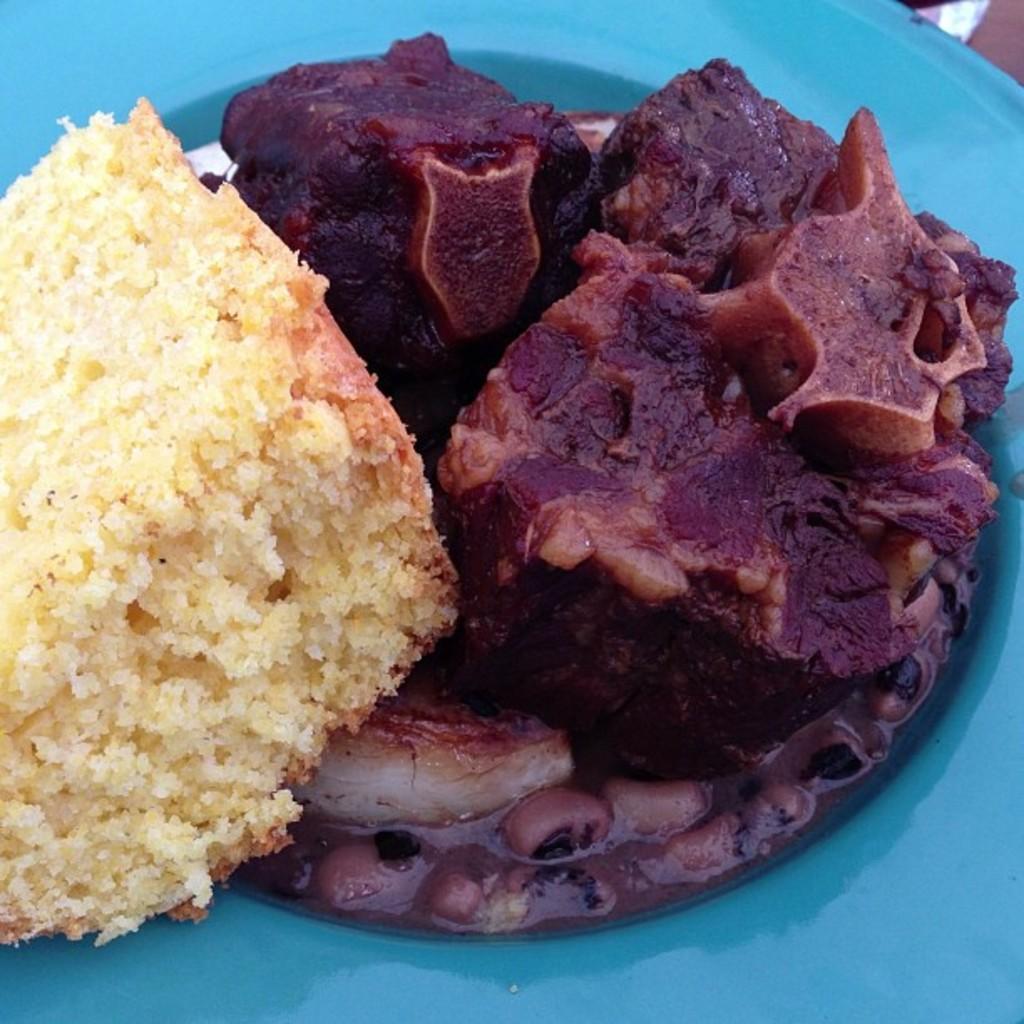Could you give a brief overview of what you see in this image? In the image there is food,meat and bread pieces in a plate. 